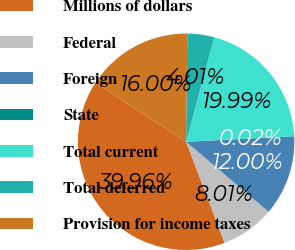Convert chart to OTSL. <chart><loc_0><loc_0><loc_500><loc_500><pie_chart><fcel>Millions of dollars<fcel>Federal<fcel>Foreign<fcel>State<fcel>Total current<fcel>Total deferred<fcel>Provision for income taxes<nl><fcel>39.96%<fcel>8.01%<fcel>12.0%<fcel>0.02%<fcel>19.99%<fcel>4.01%<fcel>16.0%<nl></chart> 